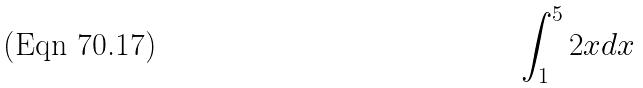Convert formula to latex. <formula><loc_0><loc_0><loc_500><loc_500>\int _ { 1 } ^ { 5 } 2 x d x</formula> 